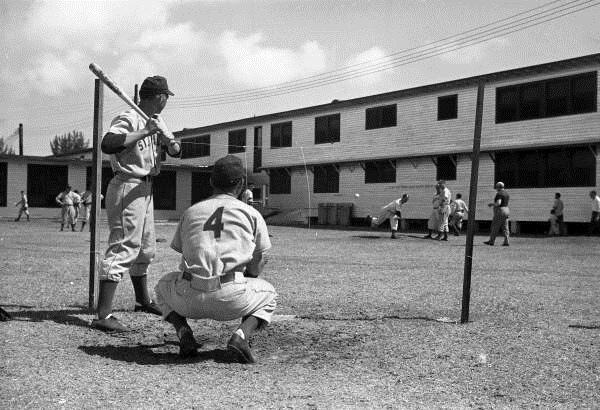What kind of event are the men participating in?
Quick response, please. Baseball. Is this a current photo?
Be succinct. No. Who is holding the bat?
Quick response, please. Batter. Where might the ball go if he hits?
Quick response, please. Building. What are the couple doing?
Be succinct. Playing baseball. 